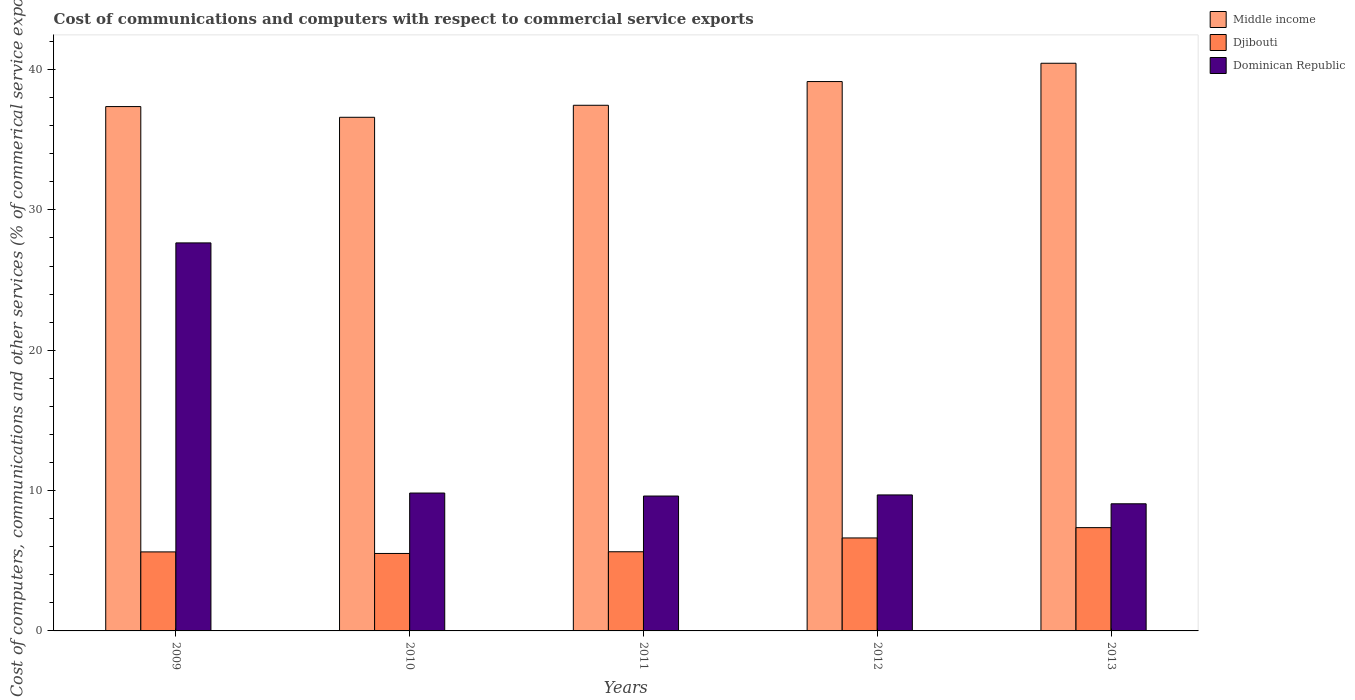How many different coloured bars are there?
Make the answer very short. 3. Are the number of bars per tick equal to the number of legend labels?
Offer a very short reply. Yes. Are the number of bars on each tick of the X-axis equal?
Your answer should be compact. Yes. How many bars are there on the 3rd tick from the right?
Keep it short and to the point. 3. In how many cases, is the number of bars for a given year not equal to the number of legend labels?
Provide a succinct answer. 0. What is the cost of communications and computers in Dominican Republic in 2011?
Keep it short and to the point. 9.61. Across all years, what is the maximum cost of communications and computers in Djibouti?
Ensure brevity in your answer.  7.36. Across all years, what is the minimum cost of communications and computers in Djibouti?
Provide a short and direct response. 5.52. In which year was the cost of communications and computers in Dominican Republic minimum?
Ensure brevity in your answer.  2013. What is the total cost of communications and computers in Dominican Republic in the graph?
Provide a short and direct response. 65.83. What is the difference between the cost of communications and computers in Dominican Republic in 2010 and that in 2013?
Offer a very short reply. 0.77. What is the difference between the cost of communications and computers in Dominican Republic in 2009 and the cost of communications and computers in Djibouti in 2012?
Offer a terse response. 21.02. What is the average cost of communications and computers in Dominican Republic per year?
Offer a terse response. 13.17. In the year 2013, what is the difference between the cost of communications and computers in Dominican Republic and cost of communications and computers in Djibouti?
Keep it short and to the point. 1.7. What is the ratio of the cost of communications and computers in Dominican Republic in 2011 to that in 2013?
Your answer should be very brief. 1.06. Is the difference between the cost of communications and computers in Dominican Republic in 2009 and 2012 greater than the difference between the cost of communications and computers in Djibouti in 2009 and 2012?
Your answer should be very brief. Yes. What is the difference between the highest and the second highest cost of communications and computers in Djibouti?
Provide a short and direct response. 0.73. What is the difference between the highest and the lowest cost of communications and computers in Djibouti?
Your answer should be compact. 1.84. In how many years, is the cost of communications and computers in Middle income greater than the average cost of communications and computers in Middle income taken over all years?
Offer a very short reply. 2. What does the 3rd bar from the left in 2011 represents?
Offer a very short reply. Dominican Republic. What does the 2nd bar from the right in 2010 represents?
Your answer should be compact. Djibouti. How many bars are there?
Your response must be concise. 15. Are all the bars in the graph horizontal?
Offer a very short reply. No. How many years are there in the graph?
Give a very brief answer. 5. Are the values on the major ticks of Y-axis written in scientific E-notation?
Your answer should be very brief. No. Where does the legend appear in the graph?
Ensure brevity in your answer.  Top right. How many legend labels are there?
Provide a succinct answer. 3. How are the legend labels stacked?
Give a very brief answer. Vertical. What is the title of the graph?
Keep it short and to the point. Cost of communications and computers with respect to commercial service exports. Does "Albania" appear as one of the legend labels in the graph?
Your response must be concise. No. What is the label or title of the X-axis?
Ensure brevity in your answer.  Years. What is the label or title of the Y-axis?
Offer a very short reply. Cost of computers, communications and other services (% of commerical service exports). What is the Cost of computers, communications and other services (% of commerical service exports) in Middle income in 2009?
Make the answer very short. 37.36. What is the Cost of computers, communications and other services (% of commerical service exports) in Djibouti in 2009?
Your answer should be very brief. 5.63. What is the Cost of computers, communications and other services (% of commerical service exports) in Dominican Republic in 2009?
Offer a very short reply. 27.65. What is the Cost of computers, communications and other services (% of commerical service exports) of Middle income in 2010?
Offer a very short reply. 36.6. What is the Cost of computers, communications and other services (% of commerical service exports) of Djibouti in 2010?
Offer a very short reply. 5.52. What is the Cost of computers, communications and other services (% of commerical service exports) in Dominican Republic in 2010?
Your response must be concise. 9.82. What is the Cost of computers, communications and other services (% of commerical service exports) in Middle income in 2011?
Offer a terse response. 37.45. What is the Cost of computers, communications and other services (% of commerical service exports) in Djibouti in 2011?
Offer a terse response. 5.64. What is the Cost of computers, communications and other services (% of commerical service exports) in Dominican Republic in 2011?
Provide a short and direct response. 9.61. What is the Cost of computers, communications and other services (% of commerical service exports) in Middle income in 2012?
Offer a terse response. 39.14. What is the Cost of computers, communications and other services (% of commerical service exports) of Djibouti in 2012?
Give a very brief answer. 6.63. What is the Cost of computers, communications and other services (% of commerical service exports) in Dominican Republic in 2012?
Your answer should be very brief. 9.69. What is the Cost of computers, communications and other services (% of commerical service exports) of Middle income in 2013?
Provide a short and direct response. 40.45. What is the Cost of computers, communications and other services (% of commerical service exports) of Djibouti in 2013?
Make the answer very short. 7.36. What is the Cost of computers, communications and other services (% of commerical service exports) in Dominican Republic in 2013?
Your answer should be very brief. 9.06. Across all years, what is the maximum Cost of computers, communications and other services (% of commerical service exports) in Middle income?
Your response must be concise. 40.45. Across all years, what is the maximum Cost of computers, communications and other services (% of commerical service exports) in Djibouti?
Provide a succinct answer. 7.36. Across all years, what is the maximum Cost of computers, communications and other services (% of commerical service exports) of Dominican Republic?
Provide a succinct answer. 27.65. Across all years, what is the minimum Cost of computers, communications and other services (% of commerical service exports) of Middle income?
Offer a terse response. 36.6. Across all years, what is the minimum Cost of computers, communications and other services (% of commerical service exports) of Djibouti?
Offer a terse response. 5.52. Across all years, what is the minimum Cost of computers, communications and other services (% of commerical service exports) of Dominican Republic?
Your response must be concise. 9.06. What is the total Cost of computers, communications and other services (% of commerical service exports) in Middle income in the graph?
Offer a terse response. 191.01. What is the total Cost of computers, communications and other services (% of commerical service exports) in Djibouti in the graph?
Provide a short and direct response. 30.77. What is the total Cost of computers, communications and other services (% of commerical service exports) in Dominican Republic in the graph?
Provide a short and direct response. 65.83. What is the difference between the Cost of computers, communications and other services (% of commerical service exports) of Middle income in 2009 and that in 2010?
Offer a very short reply. 0.76. What is the difference between the Cost of computers, communications and other services (% of commerical service exports) in Djibouti in 2009 and that in 2010?
Offer a very short reply. 0.11. What is the difference between the Cost of computers, communications and other services (% of commerical service exports) in Dominican Republic in 2009 and that in 2010?
Give a very brief answer. 17.82. What is the difference between the Cost of computers, communications and other services (% of commerical service exports) of Middle income in 2009 and that in 2011?
Your answer should be very brief. -0.09. What is the difference between the Cost of computers, communications and other services (% of commerical service exports) in Djibouti in 2009 and that in 2011?
Your answer should be very brief. -0.01. What is the difference between the Cost of computers, communications and other services (% of commerical service exports) of Dominican Republic in 2009 and that in 2011?
Your response must be concise. 18.04. What is the difference between the Cost of computers, communications and other services (% of commerical service exports) of Middle income in 2009 and that in 2012?
Your answer should be compact. -1.78. What is the difference between the Cost of computers, communications and other services (% of commerical service exports) in Djibouti in 2009 and that in 2012?
Your answer should be compact. -0.99. What is the difference between the Cost of computers, communications and other services (% of commerical service exports) of Dominican Republic in 2009 and that in 2012?
Provide a succinct answer. 17.96. What is the difference between the Cost of computers, communications and other services (% of commerical service exports) in Middle income in 2009 and that in 2013?
Your answer should be very brief. -3.09. What is the difference between the Cost of computers, communications and other services (% of commerical service exports) in Djibouti in 2009 and that in 2013?
Ensure brevity in your answer.  -1.73. What is the difference between the Cost of computers, communications and other services (% of commerical service exports) in Dominican Republic in 2009 and that in 2013?
Ensure brevity in your answer.  18.59. What is the difference between the Cost of computers, communications and other services (% of commerical service exports) in Middle income in 2010 and that in 2011?
Your answer should be compact. -0.86. What is the difference between the Cost of computers, communications and other services (% of commerical service exports) in Djibouti in 2010 and that in 2011?
Your response must be concise. -0.12. What is the difference between the Cost of computers, communications and other services (% of commerical service exports) in Dominican Republic in 2010 and that in 2011?
Make the answer very short. 0.21. What is the difference between the Cost of computers, communications and other services (% of commerical service exports) in Middle income in 2010 and that in 2012?
Make the answer very short. -2.55. What is the difference between the Cost of computers, communications and other services (% of commerical service exports) in Djibouti in 2010 and that in 2012?
Provide a short and direct response. -1.11. What is the difference between the Cost of computers, communications and other services (% of commerical service exports) in Dominican Republic in 2010 and that in 2012?
Your answer should be very brief. 0.13. What is the difference between the Cost of computers, communications and other services (% of commerical service exports) in Middle income in 2010 and that in 2013?
Provide a short and direct response. -3.85. What is the difference between the Cost of computers, communications and other services (% of commerical service exports) of Djibouti in 2010 and that in 2013?
Give a very brief answer. -1.84. What is the difference between the Cost of computers, communications and other services (% of commerical service exports) of Dominican Republic in 2010 and that in 2013?
Offer a very short reply. 0.77. What is the difference between the Cost of computers, communications and other services (% of commerical service exports) in Middle income in 2011 and that in 2012?
Provide a succinct answer. -1.69. What is the difference between the Cost of computers, communications and other services (% of commerical service exports) of Djibouti in 2011 and that in 2012?
Provide a short and direct response. -0.98. What is the difference between the Cost of computers, communications and other services (% of commerical service exports) in Dominican Republic in 2011 and that in 2012?
Ensure brevity in your answer.  -0.08. What is the difference between the Cost of computers, communications and other services (% of commerical service exports) of Middle income in 2011 and that in 2013?
Offer a very short reply. -2.99. What is the difference between the Cost of computers, communications and other services (% of commerical service exports) of Djibouti in 2011 and that in 2013?
Give a very brief answer. -1.72. What is the difference between the Cost of computers, communications and other services (% of commerical service exports) in Dominican Republic in 2011 and that in 2013?
Give a very brief answer. 0.55. What is the difference between the Cost of computers, communications and other services (% of commerical service exports) in Middle income in 2012 and that in 2013?
Offer a terse response. -1.3. What is the difference between the Cost of computers, communications and other services (% of commerical service exports) of Djibouti in 2012 and that in 2013?
Offer a very short reply. -0.73. What is the difference between the Cost of computers, communications and other services (% of commerical service exports) in Dominican Republic in 2012 and that in 2013?
Provide a short and direct response. 0.63. What is the difference between the Cost of computers, communications and other services (% of commerical service exports) in Middle income in 2009 and the Cost of computers, communications and other services (% of commerical service exports) in Djibouti in 2010?
Your response must be concise. 31.84. What is the difference between the Cost of computers, communications and other services (% of commerical service exports) of Middle income in 2009 and the Cost of computers, communications and other services (% of commerical service exports) of Dominican Republic in 2010?
Ensure brevity in your answer.  27.54. What is the difference between the Cost of computers, communications and other services (% of commerical service exports) of Djibouti in 2009 and the Cost of computers, communications and other services (% of commerical service exports) of Dominican Republic in 2010?
Provide a short and direct response. -4.19. What is the difference between the Cost of computers, communications and other services (% of commerical service exports) of Middle income in 2009 and the Cost of computers, communications and other services (% of commerical service exports) of Djibouti in 2011?
Keep it short and to the point. 31.72. What is the difference between the Cost of computers, communications and other services (% of commerical service exports) in Middle income in 2009 and the Cost of computers, communications and other services (% of commerical service exports) in Dominican Republic in 2011?
Your answer should be compact. 27.75. What is the difference between the Cost of computers, communications and other services (% of commerical service exports) in Djibouti in 2009 and the Cost of computers, communications and other services (% of commerical service exports) in Dominican Republic in 2011?
Offer a very short reply. -3.98. What is the difference between the Cost of computers, communications and other services (% of commerical service exports) of Middle income in 2009 and the Cost of computers, communications and other services (% of commerical service exports) of Djibouti in 2012?
Make the answer very short. 30.74. What is the difference between the Cost of computers, communications and other services (% of commerical service exports) of Middle income in 2009 and the Cost of computers, communications and other services (% of commerical service exports) of Dominican Republic in 2012?
Provide a short and direct response. 27.67. What is the difference between the Cost of computers, communications and other services (% of commerical service exports) in Djibouti in 2009 and the Cost of computers, communications and other services (% of commerical service exports) in Dominican Republic in 2012?
Your answer should be very brief. -4.06. What is the difference between the Cost of computers, communications and other services (% of commerical service exports) in Middle income in 2009 and the Cost of computers, communications and other services (% of commerical service exports) in Djibouti in 2013?
Provide a short and direct response. 30. What is the difference between the Cost of computers, communications and other services (% of commerical service exports) of Middle income in 2009 and the Cost of computers, communications and other services (% of commerical service exports) of Dominican Republic in 2013?
Provide a succinct answer. 28.3. What is the difference between the Cost of computers, communications and other services (% of commerical service exports) of Djibouti in 2009 and the Cost of computers, communications and other services (% of commerical service exports) of Dominican Republic in 2013?
Your answer should be very brief. -3.43. What is the difference between the Cost of computers, communications and other services (% of commerical service exports) of Middle income in 2010 and the Cost of computers, communications and other services (% of commerical service exports) of Djibouti in 2011?
Ensure brevity in your answer.  30.96. What is the difference between the Cost of computers, communications and other services (% of commerical service exports) in Middle income in 2010 and the Cost of computers, communications and other services (% of commerical service exports) in Dominican Republic in 2011?
Give a very brief answer. 26.99. What is the difference between the Cost of computers, communications and other services (% of commerical service exports) in Djibouti in 2010 and the Cost of computers, communications and other services (% of commerical service exports) in Dominican Republic in 2011?
Provide a succinct answer. -4.09. What is the difference between the Cost of computers, communications and other services (% of commerical service exports) in Middle income in 2010 and the Cost of computers, communications and other services (% of commerical service exports) in Djibouti in 2012?
Keep it short and to the point. 29.97. What is the difference between the Cost of computers, communications and other services (% of commerical service exports) in Middle income in 2010 and the Cost of computers, communications and other services (% of commerical service exports) in Dominican Republic in 2012?
Offer a very short reply. 26.91. What is the difference between the Cost of computers, communications and other services (% of commerical service exports) in Djibouti in 2010 and the Cost of computers, communications and other services (% of commerical service exports) in Dominican Republic in 2012?
Ensure brevity in your answer.  -4.17. What is the difference between the Cost of computers, communications and other services (% of commerical service exports) of Middle income in 2010 and the Cost of computers, communications and other services (% of commerical service exports) of Djibouti in 2013?
Your answer should be very brief. 29.24. What is the difference between the Cost of computers, communications and other services (% of commerical service exports) of Middle income in 2010 and the Cost of computers, communications and other services (% of commerical service exports) of Dominican Republic in 2013?
Ensure brevity in your answer.  27.54. What is the difference between the Cost of computers, communications and other services (% of commerical service exports) in Djibouti in 2010 and the Cost of computers, communications and other services (% of commerical service exports) in Dominican Republic in 2013?
Make the answer very short. -3.54. What is the difference between the Cost of computers, communications and other services (% of commerical service exports) in Middle income in 2011 and the Cost of computers, communications and other services (% of commerical service exports) in Djibouti in 2012?
Ensure brevity in your answer.  30.83. What is the difference between the Cost of computers, communications and other services (% of commerical service exports) in Middle income in 2011 and the Cost of computers, communications and other services (% of commerical service exports) in Dominican Republic in 2012?
Your answer should be very brief. 27.76. What is the difference between the Cost of computers, communications and other services (% of commerical service exports) of Djibouti in 2011 and the Cost of computers, communications and other services (% of commerical service exports) of Dominican Republic in 2012?
Keep it short and to the point. -4.05. What is the difference between the Cost of computers, communications and other services (% of commerical service exports) in Middle income in 2011 and the Cost of computers, communications and other services (% of commerical service exports) in Djibouti in 2013?
Ensure brevity in your answer.  30.1. What is the difference between the Cost of computers, communications and other services (% of commerical service exports) in Middle income in 2011 and the Cost of computers, communications and other services (% of commerical service exports) in Dominican Republic in 2013?
Your answer should be very brief. 28.4. What is the difference between the Cost of computers, communications and other services (% of commerical service exports) of Djibouti in 2011 and the Cost of computers, communications and other services (% of commerical service exports) of Dominican Republic in 2013?
Ensure brevity in your answer.  -3.42. What is the difference between the Cost of computers, communications and other services (% of commerical service exports) of Middle income in 2012 and the Cost of computers, communications and other services (% of commerical service exports) of Djibouti in 2013?
Provide a short and direct response. 31.79. What is the difference between the Cost of computers, communications and other services (% of commerical service exports) in Middle income in 2012 and the Cost of computers, communications and other services (% of commerical service exports) in Dominican Republic in 2013?
Make the answer very short. 30.09. What is the difference between the Cost of computers, communications and other services (% of commerical service exports) in Djibouti in 2012 and the Cost of computers, communications and other services (% of commerical service exports) in Dominican Republic in 2013?
Offer a very short reply. -2.43. What is the average Cost of computers, communications and other services (% of commerical service exports) of Middle income per year?
Keep it short and to the point. 38.2. What is the average Cost of computers, communications and other services (% of commerical service exports) of Djibouti per year?
Your answer should be compact. 6.15. What is the average Cost of computers, communications and other services (% of commerical service exports) of Dominican Republic per year?
Your answer should be very brief. 13.17. In the year 2009, what is the difference between the Cost of computers, communications and other services (% of commerical service exports) in Middle income and Cost of computers, communications and other services (% of commerical service exports) in Djibouti?
Provide a succinct answer. 31.73. In the year 2009, what is the difference between the Cost of computers, communications and other services (% of commerical service exports) of Middle income and Cost of computers, communications and other services (% of commerical service exports) of Dominican Republic?
Your response must be concise. 9.71. In the year 2009, what is the difference between the Cost of computers, communications and other services (% of commerical service exports) of Djibouti and Cost of computers, communications and other services (% of commerical service exports) of Dominican Republic?
Keep it short and to the point. -22.02. In the year 2010, what is the difference between the Cost of computers, communications and other services (% of commerical service exports) in Middle income and Cost of computers, communications and other services (% of commerical service exports) in Djibouti?
Your response must be concise. 31.08. In the year 2010, what is the difference between the Cost of computers, communications and other services (% of commerical service exports) of Middle income and Cost of computers, communications and other services (% of commerical service exports) of Dominican Republic?
Keep it short and to the point. 26.77. In the year 2010, what is the difference between the Cost of computers, communications and other services (% of commerical service exports) of Djibouti and Cost of computers, communications and other services (% of commerical service exports) of Dominican Republic?
Give a very brief answer. -4.3. In the year 2011, what is the difference between the Cost of computers, communications and other services (% of commerical service exports) of Middle income and Cost of computers, communications and other services (% of commerical service exports) of Djibouti?
Give a very brief answer. 31.81. In the year 2011, what is the difference between the Cost of computers, communications and other services (% of commerical service exports) of Middle income and Cost of computers, communications and other services (% of commerical service exports) of Dominican Republic?
Keep it short and to the point. 27.84. In the year 2011, what is the difference between the Cost of computers, communications and other services (% of commerical service exports) in Djibouti and Cost of computers, communications and other services (% of commerical service exports) in Dominican Republic?
Make the answer very short. -3.97. In the year 2012, what is the difference between the Cost of computers, communications and other services (% of commerical service exports) in Middle income and Cost of computers, communications and other services (% of commerical service exports) in Djibouti?
Keep it short and to the point. 32.52. In the year 2012, what is the difference between the Cost of computers, communications and other services (% of commerical service exports) of Middle income and Cost of computers, communications and other services (% of commerical service exports) of Dominican Republic?
Ensure brevity in your answer.  29.45. In the year 2012, what is the difference between the Cost of computers, communications and other services (% of commerical service exports) of Djibouti and Cost of computers, communications and other services (% of commerical service exports) of Dominican Republic?
Keep it short and to the point. -3.06. In the year 2013, what is the difference between the Cost of computers, communications and other services (% of commerical service exports) in Middle income and Cost of computers, communications and other services (% of commerical service exports) in Djibouti?
Offer a very short reply. 33.09. In the year 2013, what is the difference between the Cost of computers, communications and other services (% of commerical service exports) of Middle income and Cost of computers, communications and other services (% of commerical service exports) of Dominican Republic?
Your response must be concise. 31.39. In the year 2013, what is the difference between the Cost of computers, communications and other services (% of commerical service exports) in Djibouti and Cost of computers, communications and other services (% of commerical service exports) in Dominican Republic?
Provide a succinct answer. -1.7. What is the ratio of the Cost of computers, communications and other services (% of commerical service exports) in Middle income in 2009 to that in 2010?
Keep it short and to the point. 1.02. What is the ratio of the Cost of computers, communications and other services (% of commerical service exports) of Djibouti in 2009 to that in 2010?
Keep it short and to the point. 1.02. What is the ratio of the Cost of computers, communications and other services (% of commerical service exports) of Dominican Republic in 2009 to that in 2010?
Your answer should be very brief. 2.81. What is the ratio of the Cost of computers, communications and other services (% of commerical service exports) in Djibouti in 2009 to that in 2011?
Make the answer very short. 1. What is the ratio of the Cost of computers, communications and other services (% of commerical service exports) in Dominican Republic in 2009 to that in 2011?
Offer a terse response. 2.88. What is the ratio of the Cost of computers, communications and other services (% of commerical service exports) in Middle income in 2009 to that in 2012?
Offer a terse response. 0.95. What is the ratio of the Cost of computers, communications and other services (% of commerical service exports) in Djibouti in 2009 to that in 2012?
Your answer should be compact. 0.85. What is the ratio of the Cost of computers, communications and other services (% of commerical service exports) of Dominican Republic in 2009 to that in 2012?
Offer a terse response. 2.85. What is the ratio of the Cost of computers, communications and other services (% of commerical service exports) of Middle income in 2009 to that in 2013?
Provide a short and direct response. 0.92. What is the ratio of the Cost of computers, communications and other services (% of commerical service exports) of Djibouti in 2009 to that in 2013?
Ensure brevity in your answer.  0.77. What is the ratio of the Cost of computers, communications and other services (% of commerical service exports) in Dominican Republic in 2009 to that in 2013?
Your answer should be compact. 3.05. What is the ratio of the Cost of computers, communications and other services (% of commerical service exports) in Middle income in 2010 to that in 2011?
Keep it short and to the point. 0.98. What is the ratio of the Cost of computers, communications and other services (% of commerical service exports) in Djibouti in 2010 to that in 2011?
Make the answer very short. 0.98. What is the ratio of the Cost of computers, communications and other services (% of commerical service exports) in Dominican Republic in 2010 to that in 2011?
Your answer should be very brief. 1.02. What is the ratio of the Cost of computers, communications and other services (% of commerical service exports) of Middle income in 2010 to that in 2012?
Offer a very short reply. 0.93. What is the ratio of the Cost of computers, communications and other services (% of commerical service exports) in Djibouti in 2010 to that in 2012?
Offer a terse response. 0.83. What is the ratio of the Cost of computers, communications and other services (% of commerical service exports) in Dominican Republic in 2010 to that in 2012?
Provide a short and direct response. 1.01. What is the ratio of the Cost of computers, communications and other services (% of commerical service exports) in Middle income in 2010 to that in 2013?
Provide a succinct answer. 0.9. What is the ratio of the Cost of computers, communications and other services (% of commerical service exports) of Djibouti in 2010 to that in 2013?
Your answer should be compact. 0.75. What is the ratio of the Cost of computers, communications and other services (% of commerical service exports) of Dominican Republic in 2010 to that in 2013?
Provide a short and direct response. 1.08. What is the ratio of the Cost of computers, communications and other services (% of commerical service exports) of Middle income in 2011 to that in 2012?
Make the answer very short. 0.96. What is the ratio of the Cost of computers, communications and other services (% of commerical service exports) of Djibouti in 2011 to that in 2012?
Provide a short and direct response. 0.85. What is the ratio of the Cost of computers, communications and other services (% of commerical service exports) in Middle income in 2011 to that in 2013?
Your answer should be compact. 0.93. What is the ratio of the Cost of computers, communications and other services (% of commerical service exports) in Djibouti in 2011 to that in 2013?
Offer a terse response. 0.77. What is the ratio of the Cost of computers, communications and other services (% of commerical service exports) in Dominican Republic in 2011 to that in 2013?
Your answer should be compact. 1.06. What is the ratio of the Cost of computers, communications and other services (% of commerical service exports) in Middle income in 2012 to that in 2013?
Provide a short and direct response. 0.97. What is the ratio of the Cost of computers, communications and other services (% of commerical service exports) of Djibouti in 2012 to that in 2013?
Provide a short and direct response. 0.9. What is the ratio of the Cost of computers, communications and other services (% of commerical service exports) in Dominican Republic in 2012 to that in 2013?
Offer a very short reply. 1.07. What is the difference between the highest and the second highest Cost of computers, communications and other services (% of commerical service exports) in Middle income?
Your response must be concise. 1.3. What is the difference between the highest and the second highest Cost of computers, communications and other services (% of commerical service exports) of Djibouti?
Give a very brief answer. 0.73. What is the difference between the highest and the second highest Cost of computers, communications and other services (% of commerical service exports) of Dominican Republic?
Keep it short and to the point. 17.82. What is the difference between the highest and the lowest Cost of computers, communications and other services (% of commerical service exports) in Middle income?
Give a very brief answer. 3.85. What is the difference between the highest and the lowest Cost of computers, communications and other services (% of commerical service exports) of Djibouti?
Ensure brevity in your answer.  1.84. What is the difference between the highest and the lowest Cost of computers, communications and other services (% of commerical service exports) of Dominican Republic?
Provide a short and direct response. 18.59. 